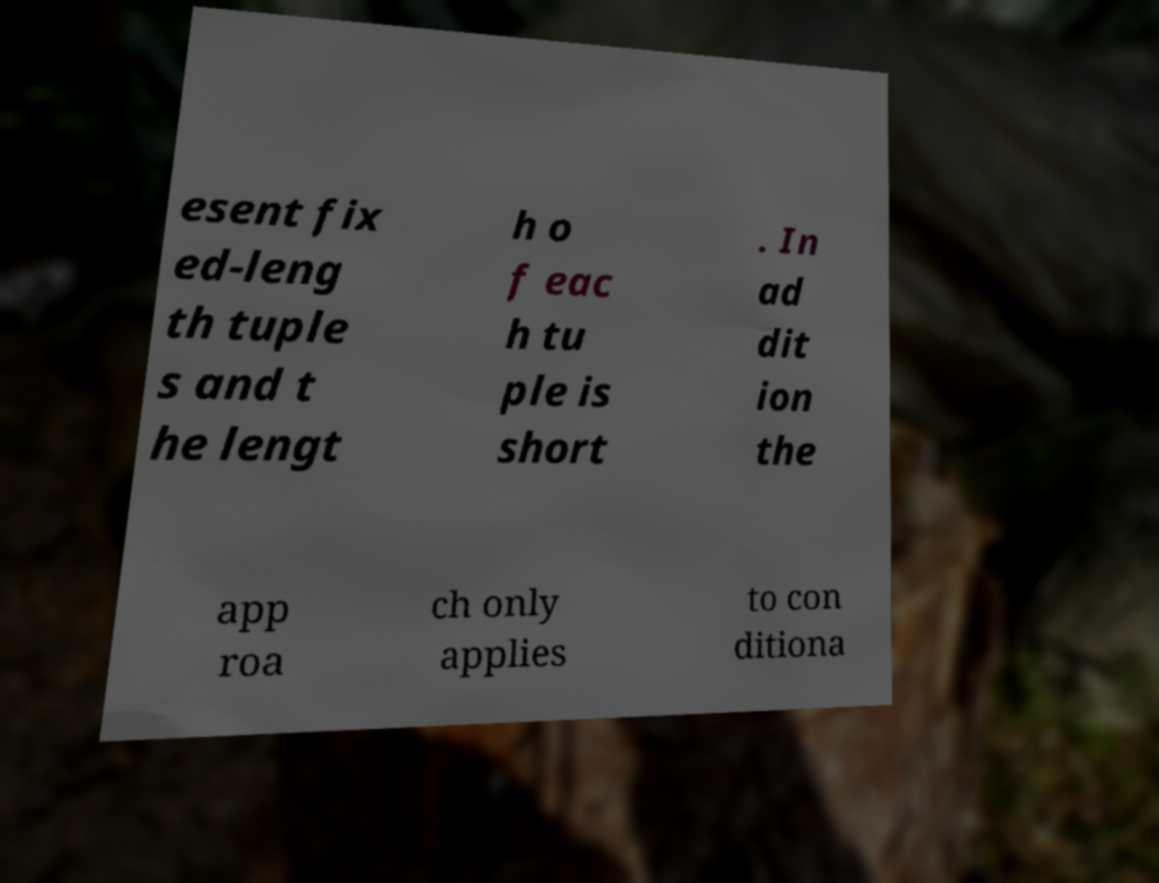For documentation purposes, I need the text within this image transcribed. Could you provide that? esent fix ed-leng th tuple s and t he lengt h o f eac h tu ple is short . In ad dit ion the app roa ch only applies to con ditiona 